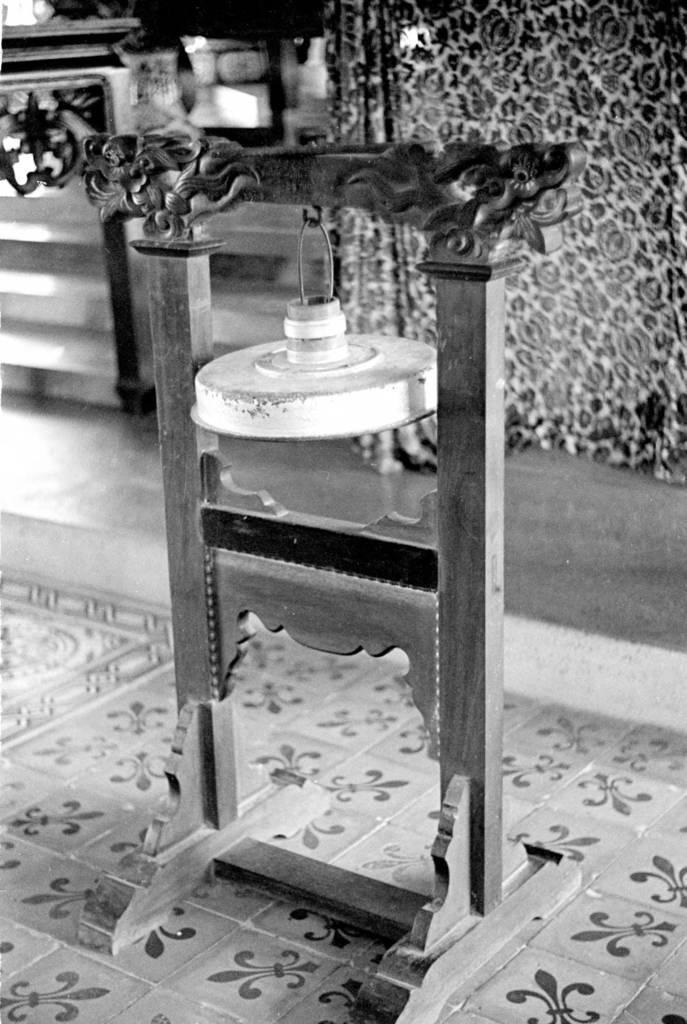Could you give a brief overview of what you see in this image? This is a black and white image. In this image there is a wooden stand on a floor. On that something is hanged. 